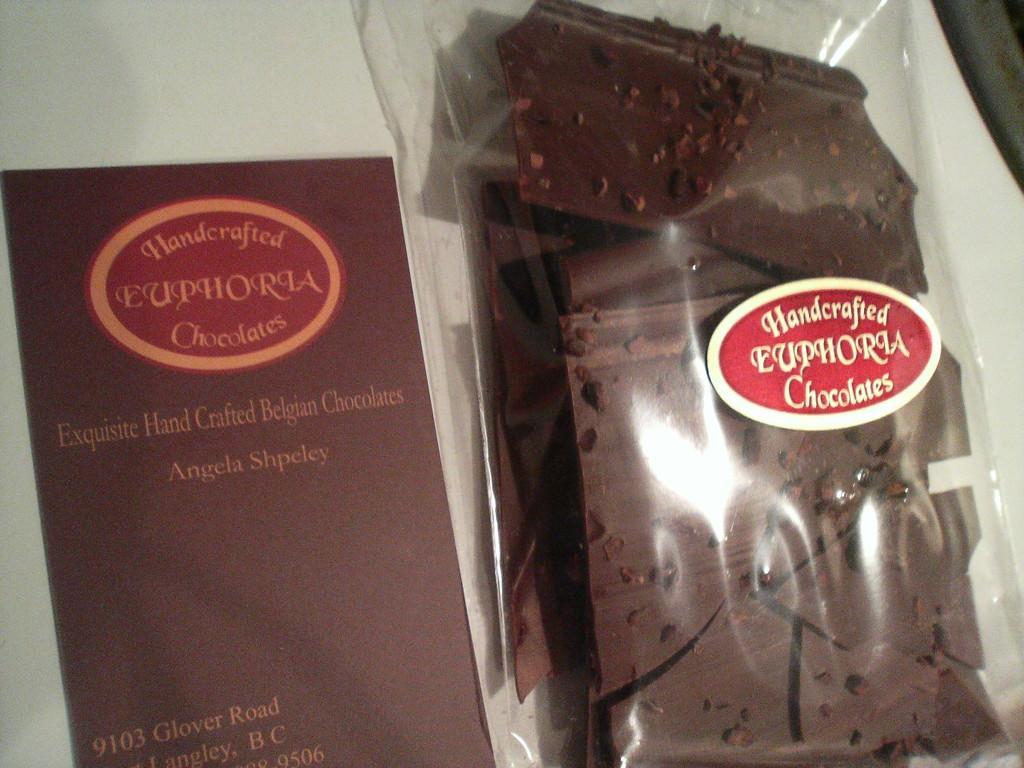Could you give a brief overview of what you see in this image? In this picture we can see a paper and few chocolates in the cover, we can find a sticker on the cover. 